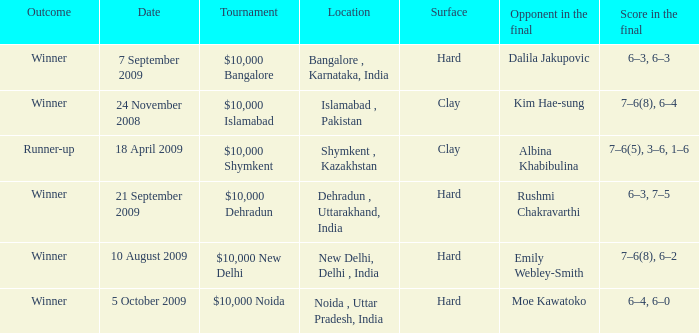Would you mind parsing the complete table? {'header': ['Outcome', 'Date', 'Tournament', 'Location', 'Surface', 'Opponent in the final', 'Score in the final'], 'rows': [['Winner', '7 September 2009', '$10,000 Bangalore', 'Bangalore , Karnataka, India', 'Hard', 'Dalila Jakupovic', '6–3, 6–3'], ['Winner', '24 November 2008', '$10,000 Islamabad', 'Islamabad , Pakistan', 'Clay', 'Kim Hae-sung', '7–6(8), 6–4'], ['Runner-up', '18 April 2009', '$10,000 Shymkent', 'Shymkent , Kazakhstan', 'Clay', 'Albina Khabibulina', '7–6(5), 3–6, 1–6'], ['Winner', '21 September 2009', '$10,000 Dehradun', 'Dehradun , Uttarakhand, India', 'Hard', 'Rushmi Chakravarthi', '6–3, 7–5'], ['Winner', '10 August 2009', '$10,000 New Delhi', 'New Delhi, Delhi , India', 'Hard', 'Emily Webley-Smith', '7–6(8), 6–2'], ['Winner', '5 October 2009', '$10,000 Noida', 'Noida , Uttar Pradesh, India', 'Hard', 'Moe Kawatoko', '6–4, 6–0']]} What is the material of the surface in noida , uttar pradesh, india Hard. 